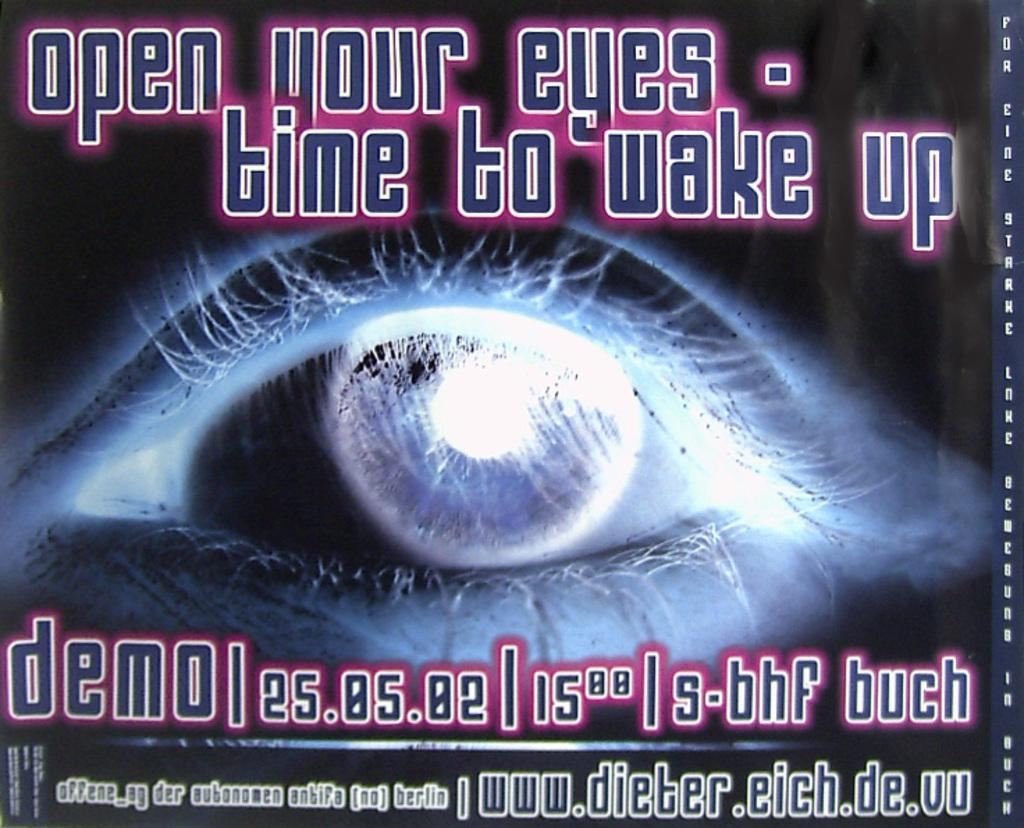Provide a one-sentence caption for the provided image. Poster that says the demo will be on the 25th. 